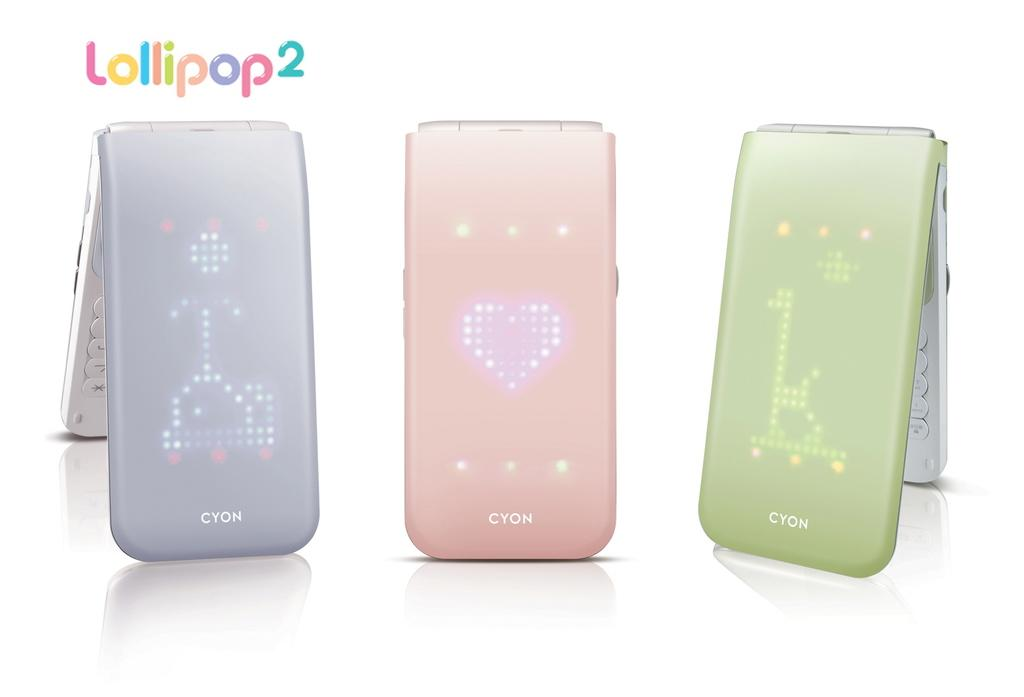<image>
Share a concise interpretation of the image provided. Three different colored CYON phones, lavender, pink and green. 